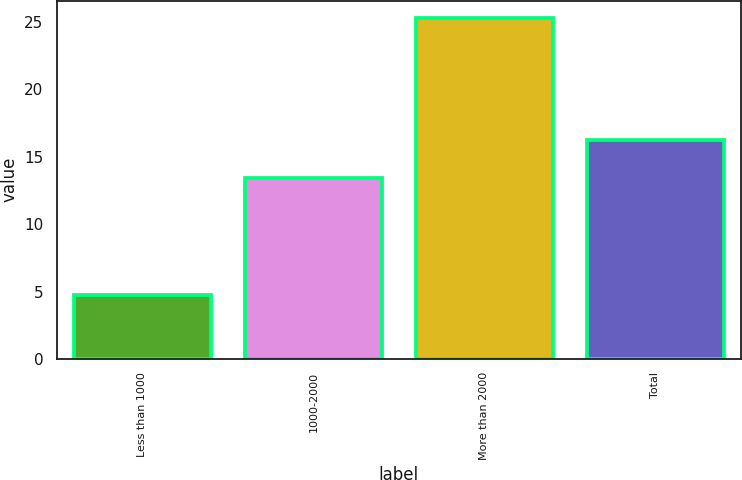<chart> <loc_0><loc_0><loc_500><loc_500><bar_chart><fcel>Less than 1000<fcel>1000-2000<fcel>More than 2000<fcel>Total<nl><fcel>4.73<fcel>13.38<fcel>25.29<fcel>16.19<nl></chart> 